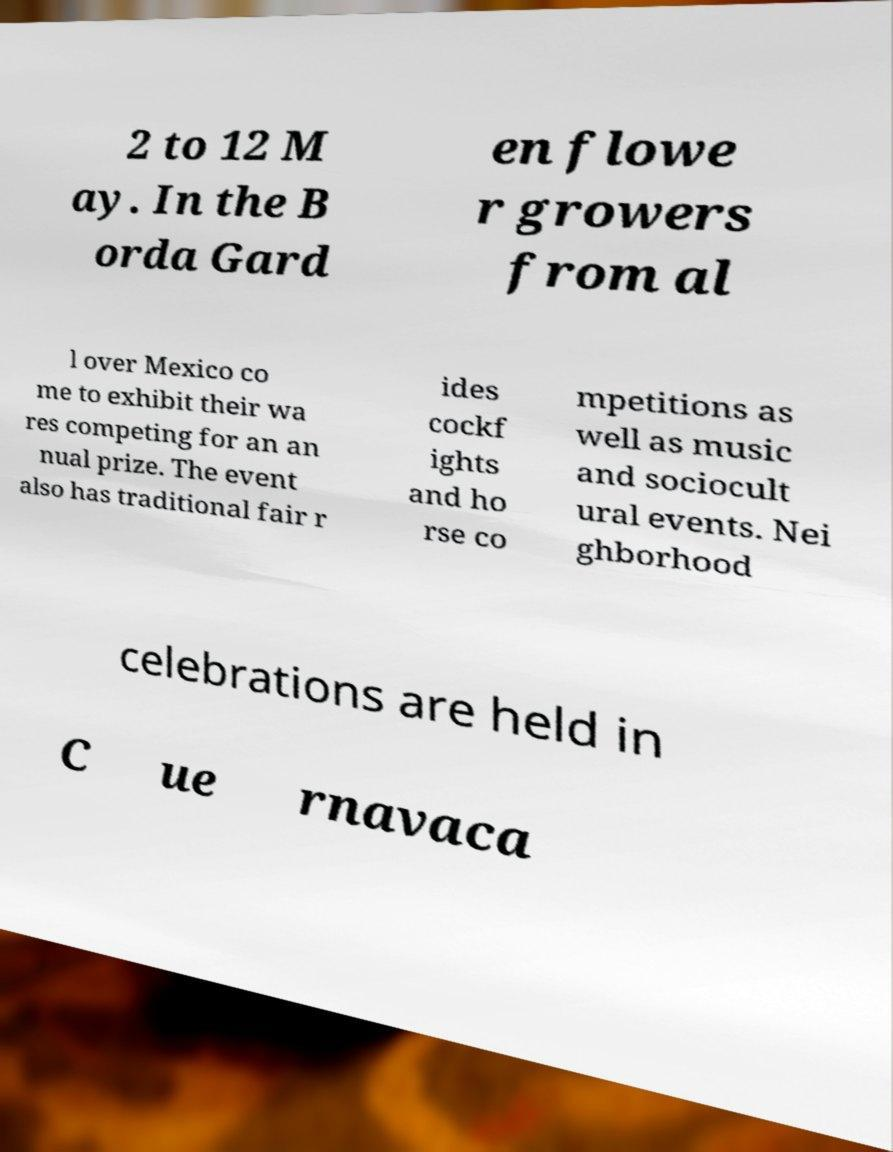I need the written content from this picture converted into text. Can you do that? 2 to 12 M ay. In the B orda Gard en flowe r growers from al l over Mexico co me to exhibit their wa res competing for an an nual prize. The event also has traditional fair r ides cockf ights and ho rse co mpetitions as well as music and sociocult ural events. Nei ghborhood celebrations are held in C ue rnavaca 